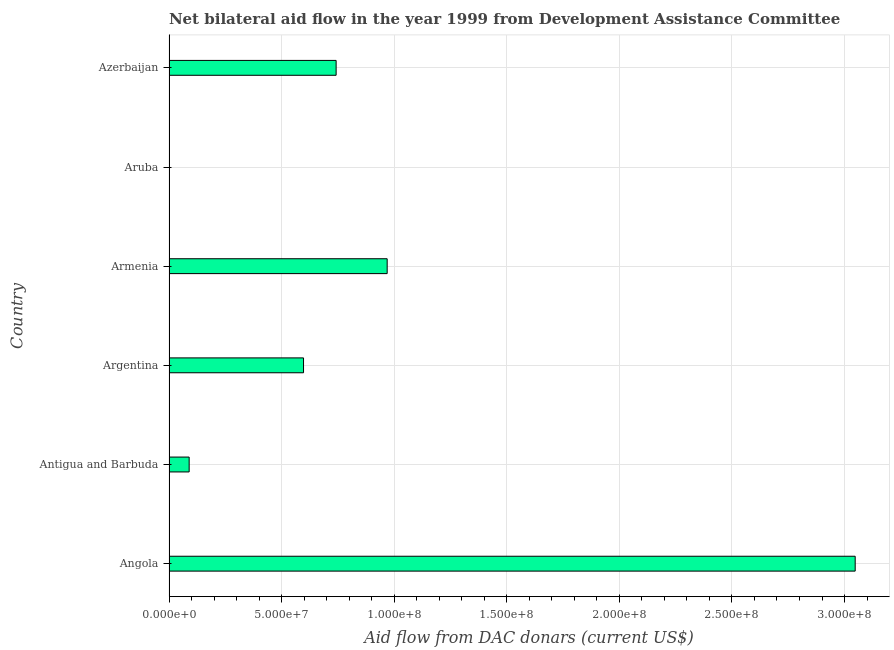Does the graph contain any zero values?
Give a very brief answer. Yes. What is the title of the graph?
Your answer should be compact. Net bilateral aid flow in the year 1999 from Development Assistance Committee. What is the label or title of the X-axis?
Your answer should be very brief. Aid flow from DAC donars (current US$). What is the net bilateral aid flows from dac donors in Angola?
Offer a terse response. 3.05e+08. Across all countries, what is the maximum net bilateral aid flows from dac donors?
Provide a short and direct response. 3.05e+08. Across all countries, what is the minimum net bilateral aid flows from dac donors?
Provide a short and direct response. 0. In which country was the net bilateral aid flows from dac donors maximum?
Your answer should be compact. Angola. What is the sum of the net bilateral aid flows from dac donors?
Keep it short and to the point. 5.45e+08. What is the difference between the net bilateral aid flows from dac donors in Angola and Argentina?
Offer a very short reply. 2.45e+08. What is the average net bilateral aid flows from dac donors per country?
Offer a very short reply. 9.08e+07. What is the median net bilateral aid flows from dac donors?
Make the answer very short. 6.70e+07. In how many countries, is the net bilateral aid flows from dac donors greater than 90000000 US$?
Provide a succinct answer. 2. What is the ratio of the net bilateral aid flows from dac donors in Angola to that in Antigua and Barbuda?
Offer a terse response. 34.05. Is the net bilateral aid flows from dac donors in Armenia less than that in Azerbaijan?
Ensure brevity in your answer.  No. What is the difference between the highest and the second highest net bilateral aid flows from dac donors?
Make the answer very short. 2.08e+08. What is the difference between the highest and the lowest net bilateral aid flows from dac donors?
Offer a very short reply. 3.05e+08. How many bars are there?
Keep it short and to the point. 5. How many countries are there in the graph?
Ensure brevity in your answer.  6. What is the difference between two consecutive major ticks on the X-axis?
Your response must be concise. 5.00e+07. What is the Aid flow from DAC donars (current US$) of Angola?
Give a very brief answer. 3.05e+08. What is the Aid flow from DAC donars (current US$) in Antigua and Barbuda?
Keep it short and to the point. 8.95e+06. What is the Aid flow from DAC donars (current US$) of Argentina?
Provide a succinct answer. 5.98e+07. What is the Aid flow from DAC donars (current US$) of Armenia?
Make the answer very short. 9.69e+07. What is the Aid flow from DAC donars (current US$) of Azerbaijan?
Ensure brevity in your answer.  7.42e+07. What is the difference between the Aid flow from DAC donars (current US$) in Angola and Antigua and Barbuda?
Give a very brief answer. 2.96e+08. What is the difference between the Aid flow from DAC donars (current US$) in Angola and Argentina?
Ensure brevity in your answer.  2.45e+08. What is the difference between the Aid flow from DAC donars (current US$) in Angola and Armenia?
Your answer should be very brief. 2.08e+08. What is the difference between the Aid flow from DAC donars (current US$) in Angola and Azerbaijan?
Your answer should be compact. 2.31e+08. What is the difference between the Aid flow from DAC donars (current US$) in Antigua and Barbuda and Argentina?
Make the answer very short. -5.08e+07. What is the difference between the Aid flow from DAC donars (current US$) in Antigua and Barbuda and Armenia?
Give a very brief answer. -8.79e+07. What is the difference between the Aid flow from DAC donars (current US$) in Antigua and Barbuda and Azerbaijan?
Ensure brevity in your answer.  -6.53e+07. What is the difference between the Aid flow from DAC donars (current US$) in Argentina and Armenia?
Your answer should be very brief. -3.71e+07. What is the difference between the Aid flow from DAC donars (current US$) in Argentina and Azerbaijan?
Your answer should be very brief. -1.45e+07. What is the difference between the Aid flow from DAC donars (current US$) in Armenia and Azerbaijan?
Keep it short and to the point. 2.27e+07. What is the ratio of the Aid flow from DAC donars (current US$) in Angola to that in Antigua and Barbuda?
Your answer should be very brief. 34.05. What is the ratio of the Aid flow from DAC donars (current US$) in Angola to that in Armenia?
Ensure brevity in your answer.  3.15. What is the ratio of the Aid flow from DAC donars (current US$) in Angola to that in Azerbaijan?
Provide a succinct answer. 4.11. What is the ratio of the Aid flow from DAC donars (current US$) in Antigua and Barbuda to that in Argentina?
Keep it short and to the point. 0.15. What is the ratio of the Aid flow from DAC donars (current US$) in Antigua and Barbuda to that in Armenia?
Your answer should be compact. 0.09. What is the ratio of the Aid flow from DAC donars (current US$) in Antigua and Barbuda to that in Azerbaijan?
Offer a terse response. 0.12. What is the ratio of the Aid flow from DAC donars (current US$) in Argentina to that in Armenia?
Your answer should be very brief. 0.62. What is the ratio of the Aid flow from DAC donars (current US$) in Argentina to that in Azerbaijan?
Offer a terse response. 0.81. What is the ratio of the Aid flow from DAC donars (current US$) in Armenia to that in Azerbaijan?
Give a very brief answer. 1.3. 